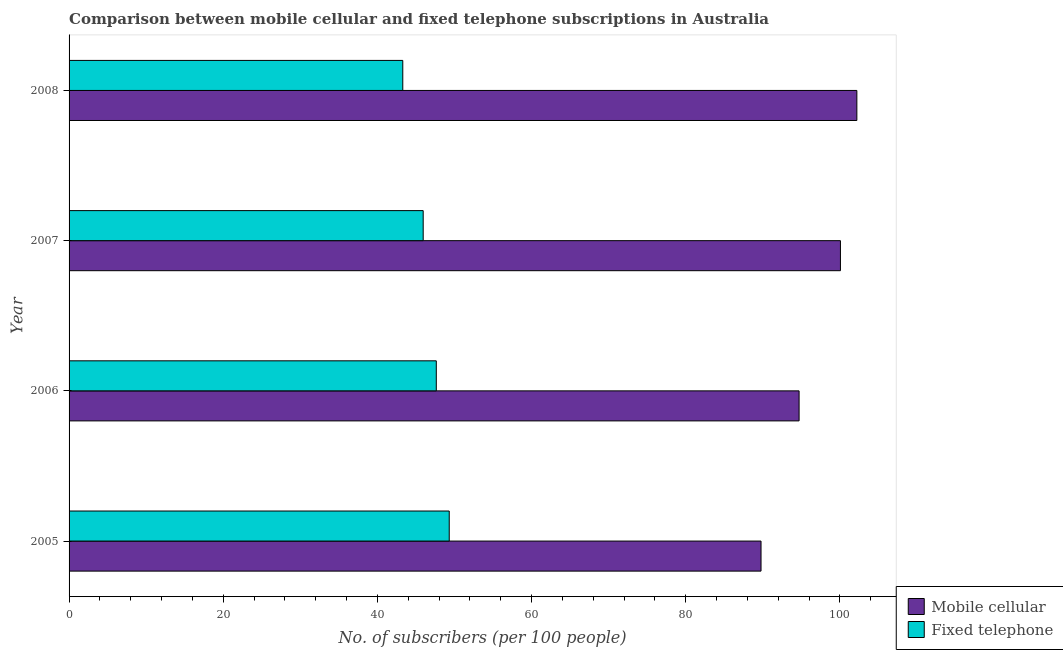How many groups of bars are there?
Your response must be concise. 4. Are the number of bars per tick equal to the number of legend labels?
Give a very brief answer. Yes. How many bars are there on the 1st tick from the top?
Offer a terse response. 2. How many bars are there on the 2nd tick from the bottom?
Your answer should be very brief. 2. What is the number of mobile cellular subscribers in 2006?
Offer a very short reply. 94.7. Across all years, what is the maximum number of fixed telephone subscribers?
Provide a short and direct response. 49.32. Across all years, what is the minimum number of mobile cellular subscribers?
Offer a terse response. 89.76. In which year was the number of mobile cellular subscribers minimum?
Your answer should be very brief. 2005. What is the total number of fixed telephone subscribers in the graph?
Offer a very short reply. 186.18. What is the difference between the number of mobile cellular subscribers in 2005 and that in 2007?
Make the answer very short. -10.3. What is the difference between the number of mobile cellular subscribers in 2007 and the number of fixed telephone subscribers in 2005?
Provide a short and direct response. 50.75. What is the average number of mobile cellular subscribers per year?
Keep it short and to the point. 96.68. In the year 2005, what is the difference between the number of fixed telephone subscribers and number of mobile cellular subscribers?
Offer a terse response. -40.45. In how many years, is the number of mobile cellular subscribers greater than 56 ?
Your answer should be very brief. 4. What is the ratio of the number of fixed telephone subscribers in 2005 to that in 2007?
Ensure brevity in your answer.  1.07. Is the number of mobile cellular subscribers in 2005 less than that in 2007?
Ensure brevity in your answer.  Yes. Is the difference between the number of fixed telephone subscribers in 2006 and 2007 greater than the difference between the number of mobile cellular subscribers in 2006 and 2007?
Offer a terse response. Yes. What is the difference between the highest and the second highest number of mobile cellular subscribers?
Your answer should be compact. 2.13. What is the difference between the highest and the lowest number of mobile cellular subscribers?
Give a very brief answer. 12.43. In how many years, is the number of mobile cellular subscribers greater than the average number of mobile cellular subscribers taken over all years?
Give a very brief answer. 2. What does the 1st bar from the top in 2008 represents?
Provide a short and direct response. Fixed telephone. What does the 2nd bar from the bottom in 2007 represents?
Keep it short and to the point. Fixed telephone. Are all the bars in the graph horizontal?
Provide a short and direct response. Yes. What is the difference between two consecutive major ticks on the X-axis?
Your answer should be very brief. 20. Where does the legend appear in the graph?
Your response must be concise. Bottom right. What is the title of the graph?
Give a very brief answer. Comparison between mobile cellular and fixed telephone subscriptions in Australia. What is the label or title of the X-axis?
Make the answer very short. No. of subscribers (per 100 people). What is the No. of subscribers (per 100 people) of Mobile cellular in 2005?
Ensure brevity in your answer.  89.76. What is the No. of subscribers (per 100 people) in Fixed telephone in 2005?
Ensure brevity in your answer.  49.32. What is the No. of subscribers (per 100 people) of Mobile cellular in 2006?
Give a very brief answer. 94.7. What is the No. of subscribers (per 100 people) of Fixed telephone in 2006?
Your answer should be very brief. 47.64. What is the No. of subscribers (per 100 people) of Mobile cellular in 2007?
Give a very brief answer. 100.06. What is the No. of subscribers (per 100 people) in Fixed telephone in 2007?
Keep it short and to the point. 45.94. What is the No. of subscribers (per 100 people) of Mobile cellular in 2008?
Ensure brevity in your answer.  102.19. What is the No. of subscribers (per 100 people) in Fixed telephone in 2008?
Your response must be concise. 43.29. Across all years, what is the maximum No. of subscribers (per 100 people) in Mobile cellular?
Give a very brief answer. 102.19. Across all years, what is the maximum No. of subscribers (per 100 people) in Fixed telephone?
Your response must be concise. 49.32. Across all years, what is the minimum No. of subscribers (per 100 people) in Mobile cellular?
Ensure brevity in your answer.  89.76. Across all years, what is the minimum No. of subscribers (per 100 people) in Fixed telephone?
Your answer should be compact. 43.29. What is the total No. of subscribers (per 100 people) of Mobile cellular in the graph?
Keep it short and to the point. 386.72. What is the total No. of subscribers (per 100 people) in Fixed telephone in the graph?
Your answer should be compact. 186.18. What is the difference between the No. of subscribers (per 100 people) of Mobile cellular in 2005 and that in 2006?
Offer a terse response. -4.94. What is the difference between the No. of subscribers (per 100 people) in Fixed telephone in 2005 and that in 2006?
Provide a succinct answer. 1.68. What is the difference between the No. of subscribers (per 100 people) in Mobile cellular in 2005 and that in 2007?
Your answer should be very brief. -10.3. What is the difference between the No. of subscribers (per 100 people) in Fixed telephone in 2005 and that in 2007?
Your response must be concise. 3.38. What is the difference between the No. of subscribers (per 100 people) of Mobile cellular in 2005 and that in 2008?
Provide a succinct answer. -12.43. What is the difference between the No. of subscribers (per 100 people) of Fixed telephone in 2005 and that in 2008?
Ensure brevity in your answer.  6.03. What is the difference between the No. of subscribers (per 100 people) in Mobile cellular in 2006 and that in 2007?
Give a very brief answer. -5.36. What is the difference between the No. of subscribers (per 100 people) of Fixed telephone in 2006 and that in 2007?
Your answer should be compact. 1.7. What is the difference between the No. of subscribers (per 100 people) of Mobile cellular in 2006 and that in 2008?
Make the answer very short. -7.49. What is the difference between the No. of subscribers (per 100 people) of Fixed telephone in 2006 and that in 2008?
Ensure brevity in your answer.  4.35. What is the difference between the No. of subscribers (per 100 people) of Mobile cellular in 2007 and that in 2008?
Your answer should be compact. -2.13. What is the difference between the No. of subscribers (per 100 people) in Fixed telephone in 2007 and that in 2008?
Ensure brevity in your answer.  2.65. What is the difference between the No. of subscribers (per 100 people) in Mobile cellular in 2005 and the No. of subscribers (per 100 people) in Fixed telephone in 2006?
Keep it short and to the point. 42.12. What is the difference between the No. of subscribers (per 100 people) in Mobile cellular in 2005 and the No. of subscribers (per 100 people) in Fixed telephone in 2007?
Make the answer very short. 43.83. What is the difference between the No. of subscribers (per 100 people) of Mobile cellular in 2005 and the No. of subscribers (per 100 people) of Fixed telephone in 2008?
Make the answer very short. 46.47. What is the difference between the No. of subscribers (per 100 people) of Mobile cellular in 2006 and the No. of subscribers (per 100 people) of Fixed telephone in 2007?
Ensure brevity in your answer.  48.76. What is the difference between the No. of subscribers (per 100 people) of Mobile cellular in 2006 and the No. of subscribers (per 100 people) of Fixed telephone in 2008?
Your answer should be compact. 51.41. What is the difference between the No. of subscribers (per 100 people) of Mobile cellular in 2007 and the No. of subscribers (per 100 people) of Fixed telephone in 2008?
Offer a very short reply. 56.78. What is the average No. of subscribers (per 100 people) in Mobile cellular per year?
Give a very brief answer. 96.68. What is the average No. of subscribers (per 100 people) in Fixed telephone per year?
Your response must be concise. 46.55. In the year 2005, what is the difference between the No. of subscribers (per 100 people) of Mobile cellular and No. of subscribers (per 100 people) of Fixed telephone?
Keep it short and to the point. 40.45. In the year 2006, what is the difference between the No. of subscribers (per 100 people) in Mobile cellular and No. of subscribers (per 100 people) in Fixed telephone?
Give a very brief answer. 47.06. In the year 2007, what is the difference between the No. of subscribers (per 100 people) in Mobile cellular and No. of subscribers (per 100 people) in Fixed telephone?
Your answer should be compact. 54.13. In the year 2008, what is the difference between the No. of subscribers (per 100 people) of Mobile cellular and No. of subscribers (per 100 people) of Fixed telephone?
Provide a succinct answer. 58.9. What is the ratio of the No. of subscribers (per 100 people) in Mobile cellular in 2005 to that in 2006?
Offer a very short reply. 0.95. What is the ratio of the No. of subscribers (per 100 people) of Fixed telephone in 2005 to that in 2006?
Provide a succinct answer. 1.04. What is the ratio of the No. of subscribers (per 100 people) in Mobile cellular in 2005 to that in 2007?
Your response must be concise. 0.9. What is the ratio of the No. of subscribers (per 100 people) of Fixed telephone in 2005 to that in 2007?
Your response must be concise. 1.07. What is the ratio of the No. of subscribers (per 100 people) of Mobile cellular in 2005 to that in 2008?
Your response must be concise. 0.88. What is the ratio of the No. of subscribers (per 100 people) in Fixed telephone in 2005 to that in 2008?
Provide a short and direct response. 1.14. What is the ratio of the No. of subscribers (per 100 people) of Mobile cellular in 2006 to that in 2007?
Make the answer very short. 0.95. What is the ratio of the No. of subscribers (per 100 people) of Fixed telephone in 2006 to that in 2007?
Ensure brevity in your answer.  1.04. What is the ratio of the No. of subscribers (per 100 people) in Mobile cellular in 2006 to that in 2008?
Offer a terse response. 0.93. What is the ratio of the No. of subscribers (per 100 people) of Fixed telephone in 2006 to that in 2008?
Your response must be concise. 1.1. What is the ratio of the No. of subscribers (per 100 people) of Mobile cellular in 2007 to that in 2008?
Offer a terse response. 0.98. What is the ratio of the No. of subscribers (per 100 people) in Fixed telephone in 2007 to that in 2008?
Keep it short and to the point. 1.06. What is the difference between the highest and the second highest No. of subscribers (per 100 people) of Mobile cellular?
Your answer should be very brief. 2.13. What is the difference between the highest and the second highest No. of subscribers (per 100 people) in Fixed telephone?
Your answer should be very brief. 1.68. What is the difference between the highest and the lowest No. of subscribers (per 100 people) of Mobile cellular?
Offer a very short reply. 12.43. What is the difference between the highest and the lowest No. of subscribers (per 100 people) in Fixed telephone?
Your answer should be very brief. 6.03. 